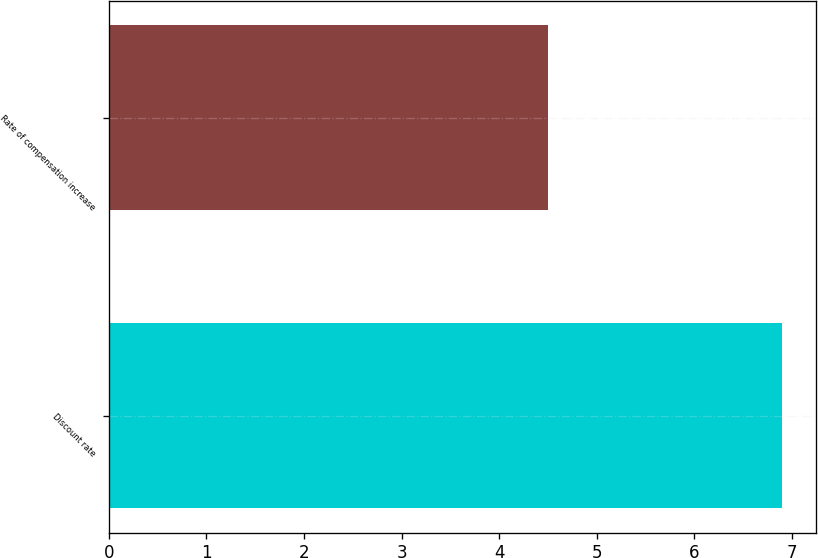Convert chart. <chart><loc_0><loc_0><loc_500><loc_500><bar_chart><fcel>Discount rate<fcel>Rate of compensation increase<nl><fcel>6.9<fcel>4.5<nl></chart> 